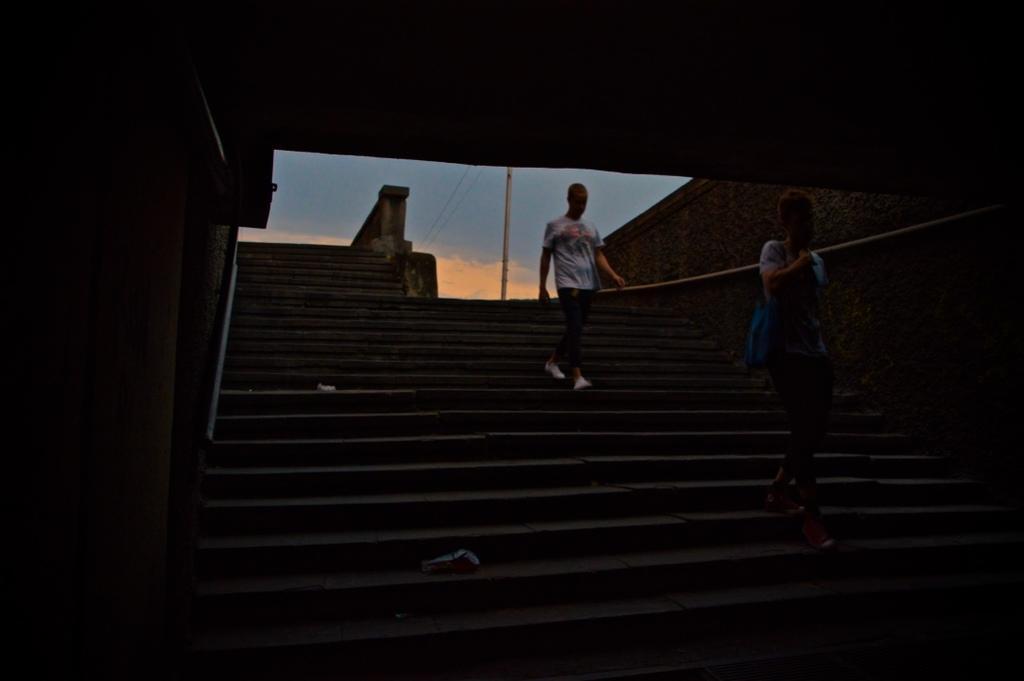Describe this image in one or two sentences. In this image we can see two persons wearing T-shirts, carrying bags walking on the stairs and at the background of the image there is pole and sky. 